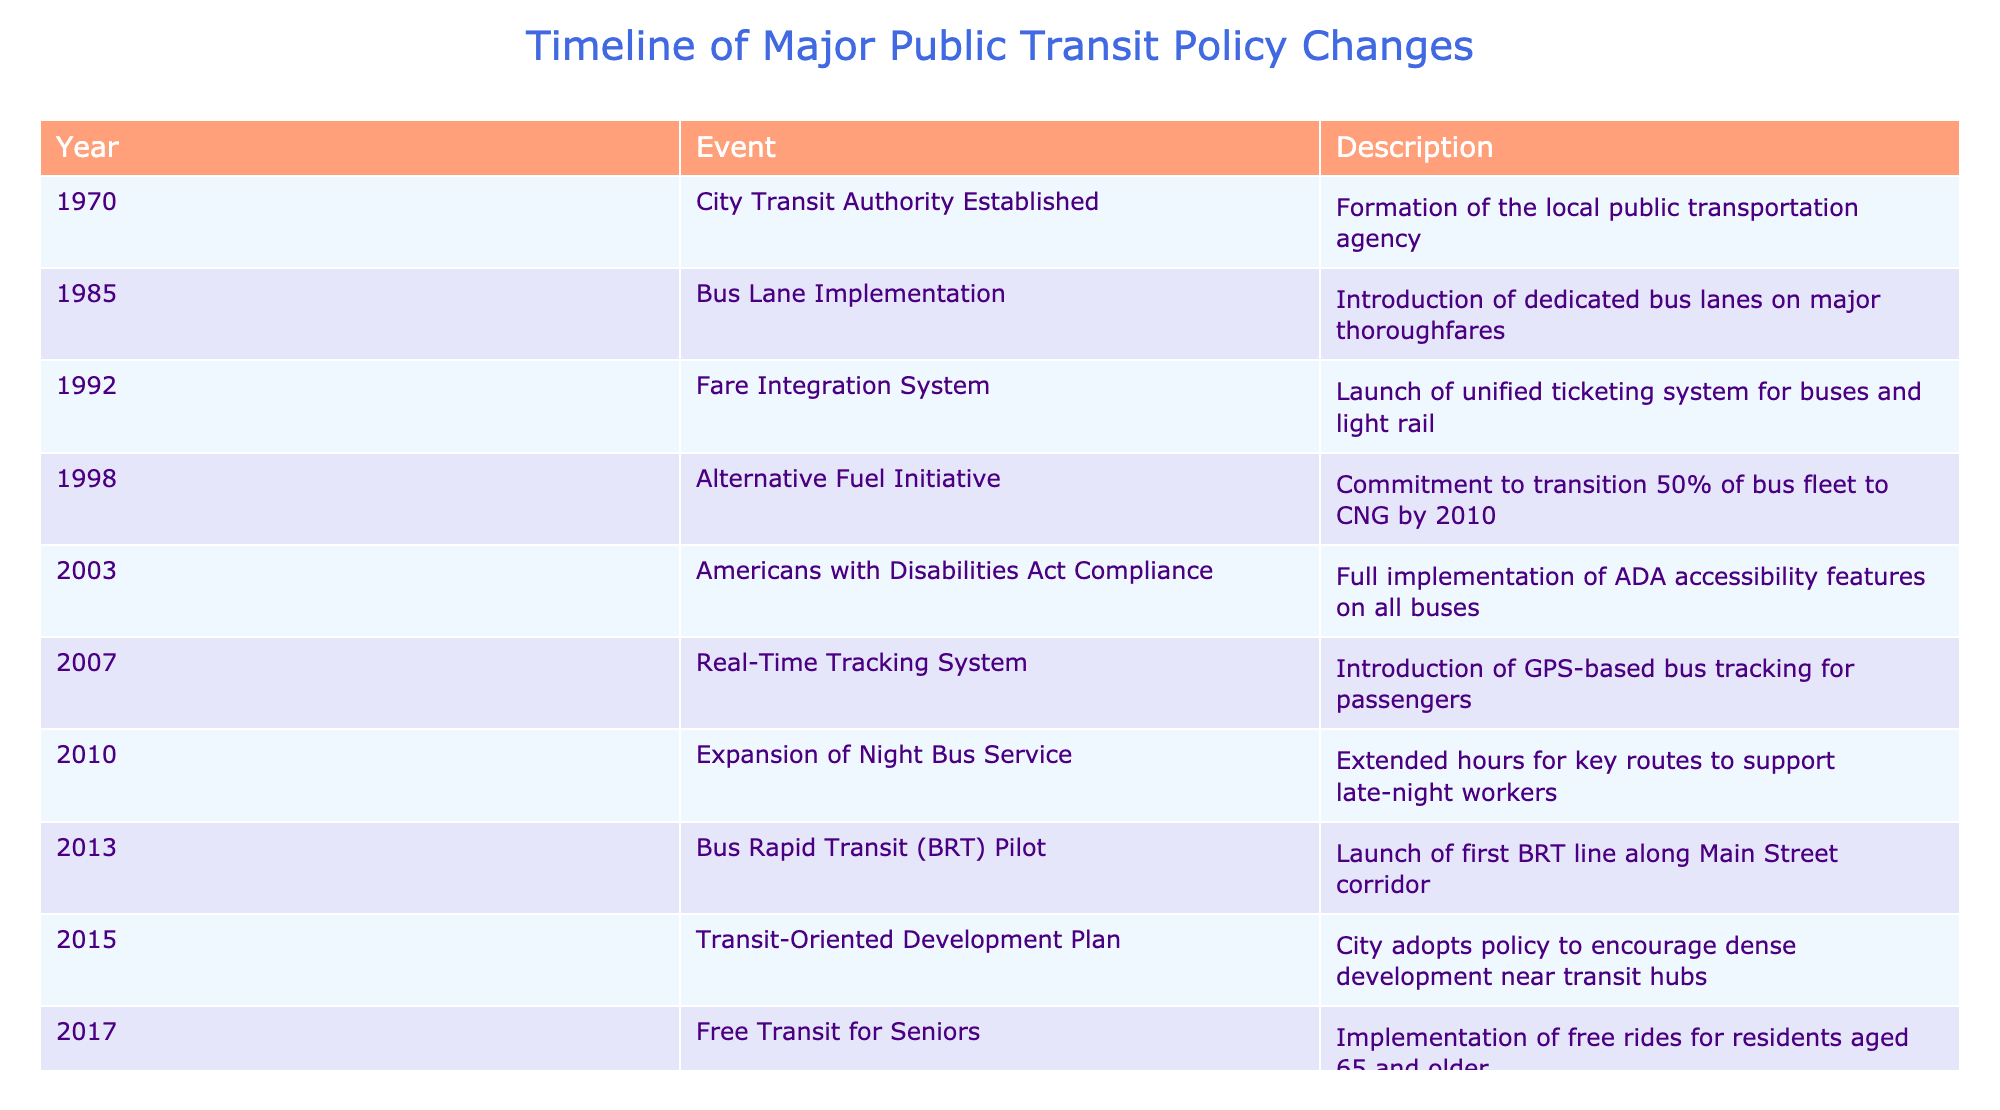What year was the City Transit Authority established? The table shows the event "City Transit Authority Established" occurred in the year 1970.
Answer: 1970 Which event introduced a unified ticketing system for buses and light rail? The event "Fare Integration System" in 1992 describes the launch of a unified ticketing system for both buses and light rail.
Answer: Fare Integration System How many years passed between the introduction of the Real-Time Tracking System and the Expansion of Night Bus Service? The Real-Time Tracking System was introduced in 2007 and the Expansion of Night Bus Service occurred in 2010. The difference is 2010 - 2007 = 3 years.
Answer: 3 years Did the policy changes include any measures for seniors to ride for free? Yes, the event "Free Transit for Seniors" in 2017 indicates that residents aged 65 and older could ride free.
Answer: Yes What was the last major policy change listed in the table? The last event in the list is "Transit Priority Signals," which occurred in 2023.
Answer: Transit Priority Signals How many major policy changes were made between 2000 and 2015? The relevant events are "Americans with Disabilities Act Compliance" (2003), "Real-Time Tracking System" (2007), "Expansion of Night Bus Service" (2010), "Bus Rapid Transit (BRT) Pilot" (2013), and "Transit-Oriented Development Plan" (2015). That's a total of 5 changes.
Answer: 5 changes Which event committed the city to transition its bus fleet to electric buses, and when was this commitment made? The event "Zero-Emission Bus Commitment" made in 2019 pledges to transition the entire bus fleet to electric by 2040.
Answer: Zero-Emission Bus Commitment, 2019 What percentage of the bus fleet was committed to transition to CNG by 2010? The "Alternative Fuel Initiative" from 1998 committed 50% of the bus fleet to CNG by 2010.
Answer: 50% What improvements were made in 2021 in response to the pandemic? The table mentions the implementation of "Pandemic Response Measures," which included enhanced cleaning protocols and capacity limits.
Answer: Enhanced cleaning and capacity limits 